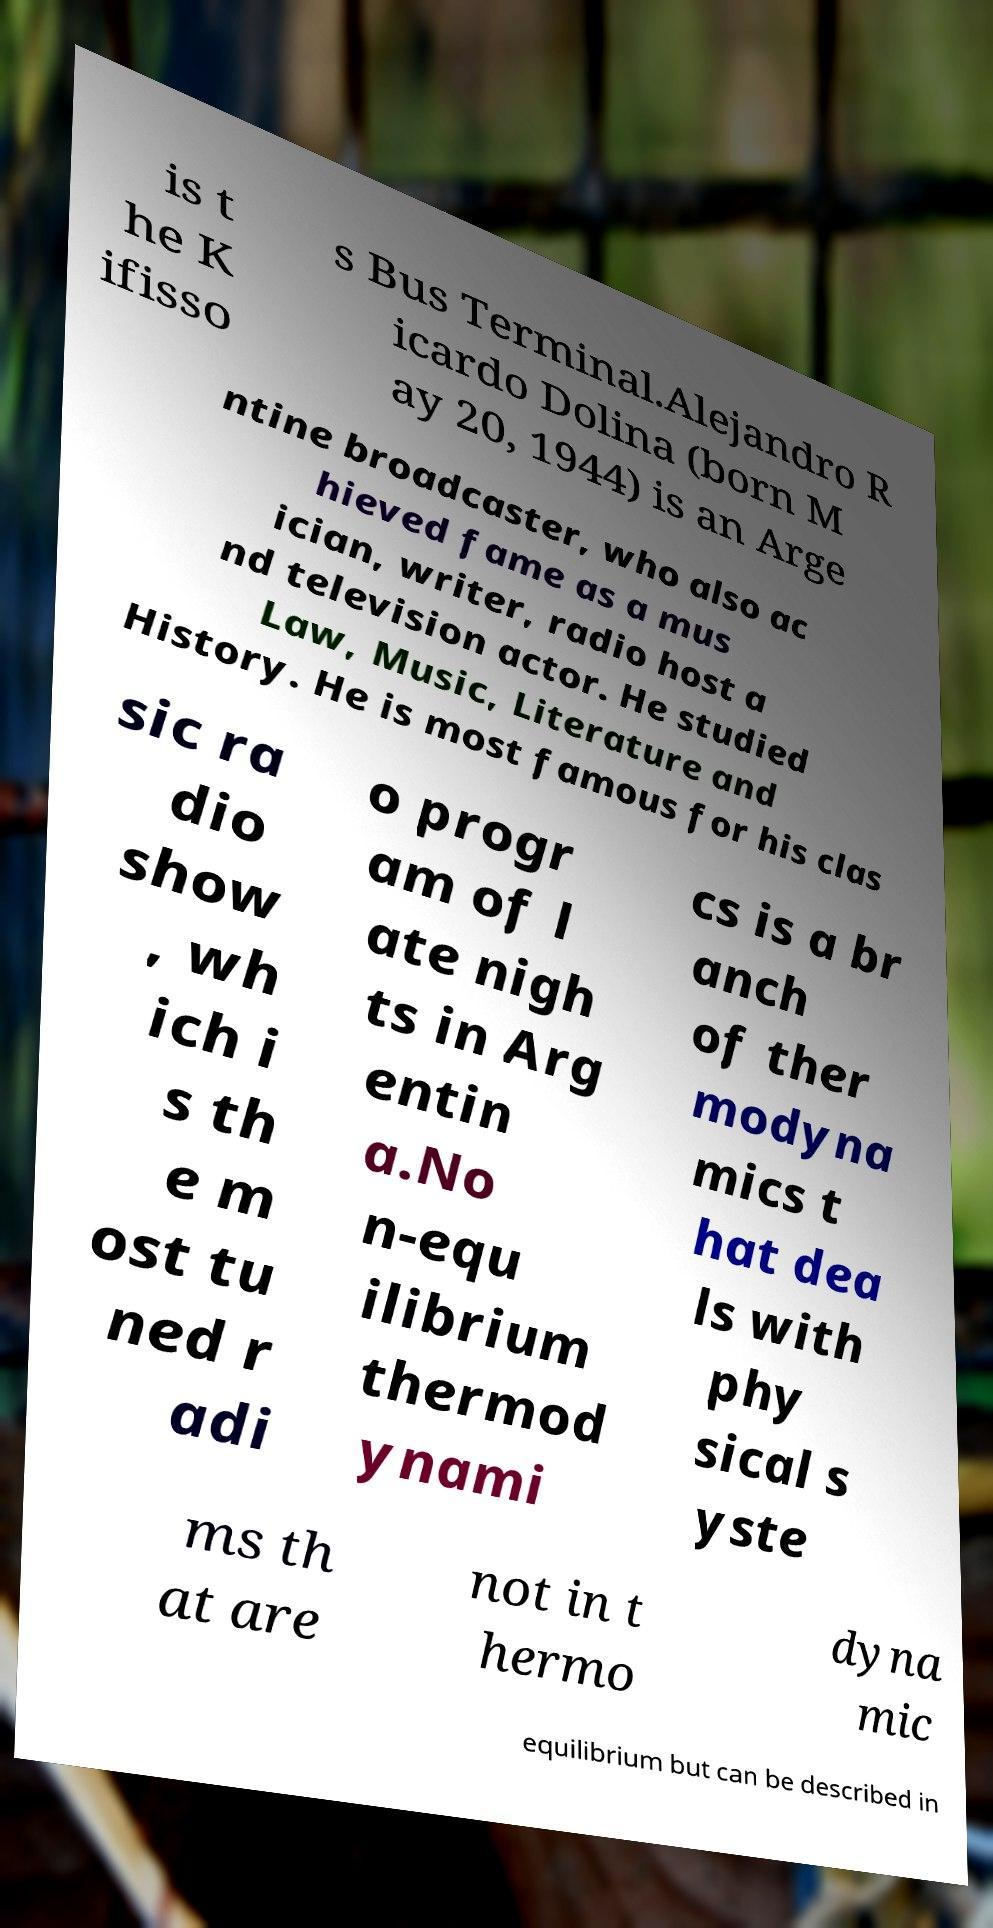For documentation purposes, I need the text within this image transcribed. Could you provide that? is t he K ifisso s Bus Terminal.Alejandro R icardo Dolina (born M ay 20, 1944) is an Arge ntine broadcaster, who also ac hieved fame as a mus ician, writer, radio host a nd television actor. He studied Law, Music, Literature and History. He is most famous for his clas sic ra dio show , wh ich i s th e m ost tu ned r adi o progr am of l ate nigh ts in Arg entin a.No n-equ ilibrium thermod ynami cs is a br anch of ther modyna mics t hat dea ls with phy sical s yste ms th at are not in t hermo dyna mic equilibrium but can be described in 